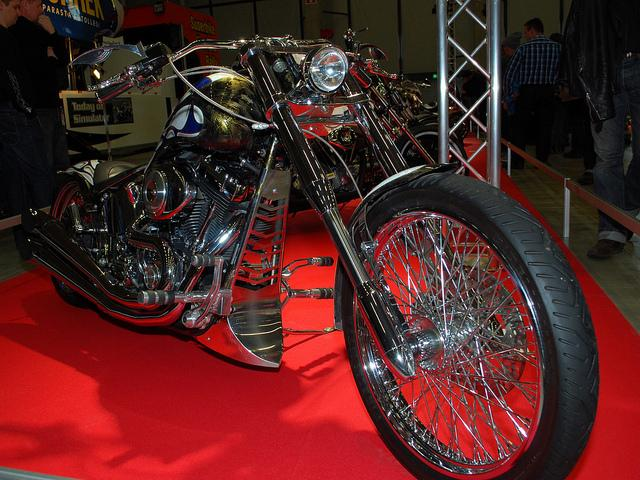Where is this bike located? Please explain your reasoning. museum. The motorcycle is on a red tarp on display for onlookers to observe. 